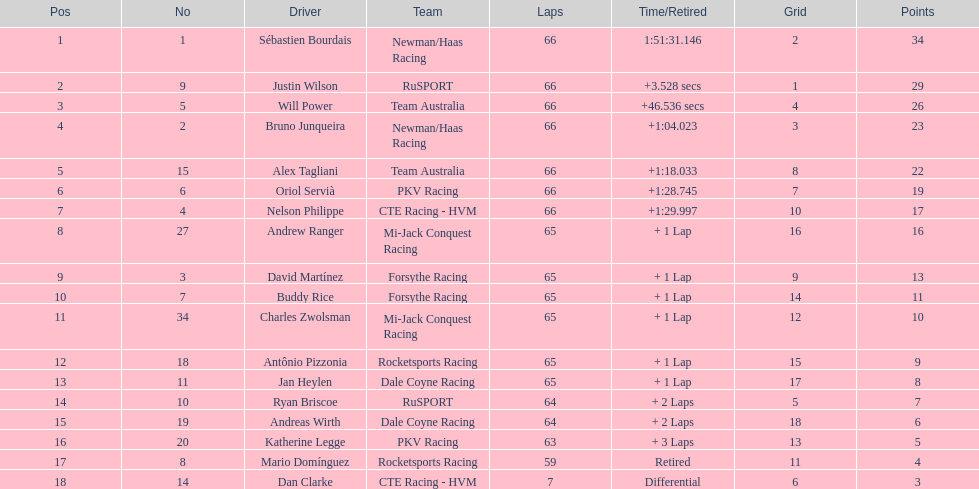Rice ended up 10th. who concluded subsequently? Charles Zwolsman. 